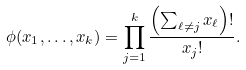<formula> <loc_0><loc_0><loc_500><loc_500>\phi ( x _ { 1 } , \dots , x _ { k } ) = \prod _ { j = 1 } ^ { k } \frac { \left ( \sum _ { \ell \neq j } x _ { \ell } \right ) ! } { x _ { j } ! } .</formula> 